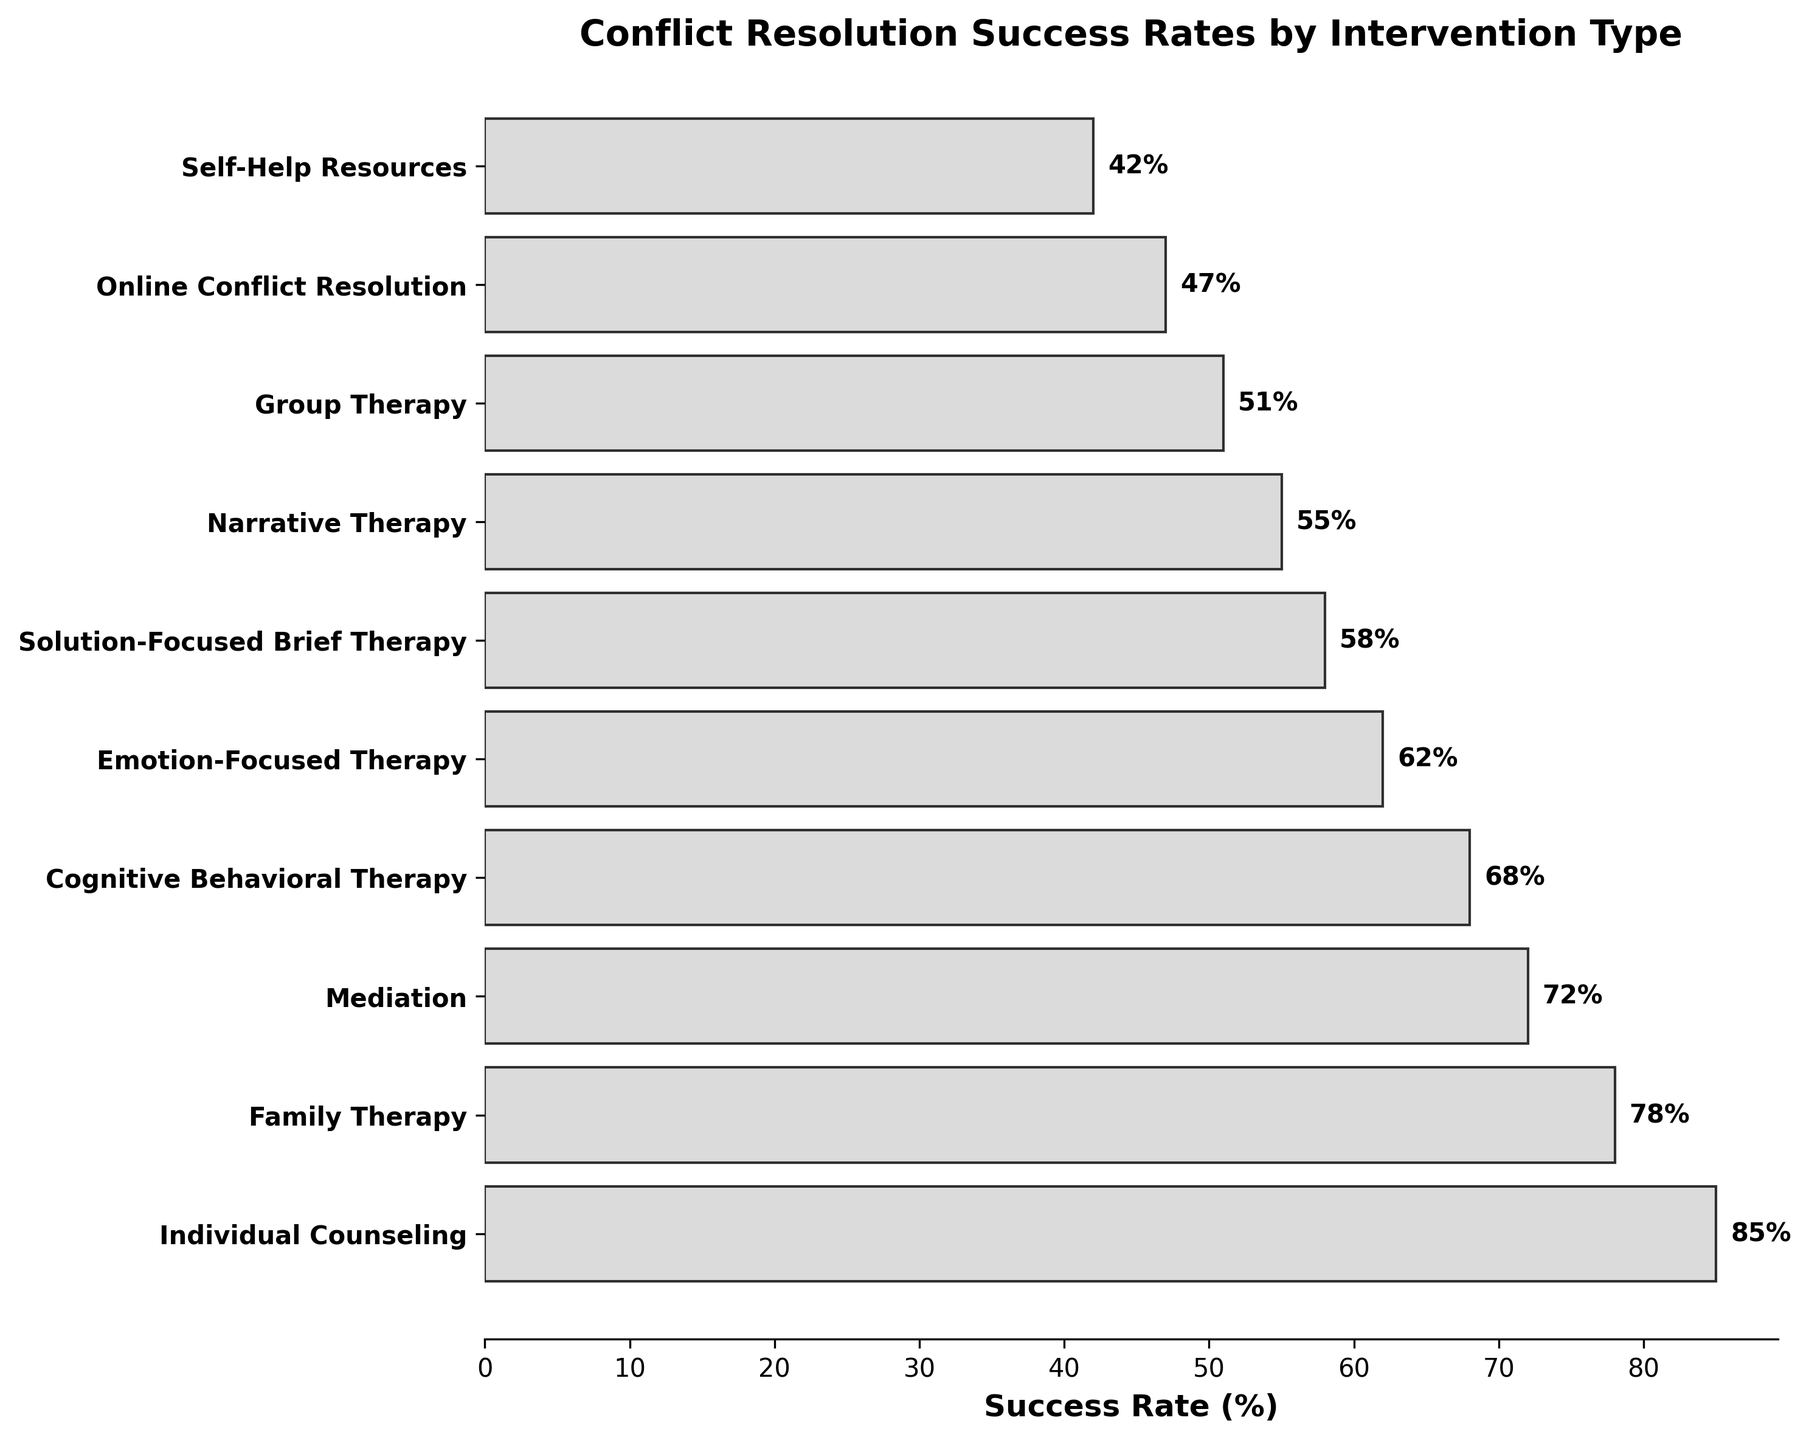What is the title of the figure? The title of the figure is displayed at the top and summarizes the main topic of the plot.
Answer: Conflict Resolution Success Rates by Intervention Type Which intervention type has the highest success rate? The highest bar on the chart represents the intervention type with the highest success rate.
Answer: Individual Counseling What is the success rate of Family Therapy? The success rate of Family Therapy can be found next to the bar labeled "Family Therapy".
Answer: 78% How many intervention types are displayed in the figure? Count the total number of bars in the funnel chart to determine the number of intervention types.
Answer: 10 Which intervention type has the lowest success rate? The shortest bar on the chart represents the intervention type with the lowest success rate.
Answer: Self-Help Resources What is the success rate difference between Individual Counseling and Mediation? Subtract the success rate of Mediation from the success rate of Individual Counseling to find the difference. \[85 (Individual Counseling) - 72 (Mediation) = 13\]
Answer: 13% Arrange the intervention types with success rates above 60% in descending order. Identify the intervention types with success rates over 60% and list them from highest to lowest success rate. \[Individual Counseling (85%), Family Therapy (78%), Mediation (72%), Cognitive Behavioral Therapy (68%), Emotion-Focused Therapy (62%)\]
Answer: Individual Counseling, Family Therapy, Mediation, Cognitive Behavioral Therapy, Emotion-Focused Therapy Which two intervention types have nearly equal success rates? Look for pairs of bars that are of similar lengths and check their labels and values. \[Solution-Focused Brief Therapy (58%) and Narrative Therapy (55%) are close to each other in success rates.\]
Answer: Solution-Focused Brief Therapy and Narrative Therapy What is the combined success rate of Group Therapy and Online Conflict Resolution? Add the success rates of Group Therapy and Online Conflict Resolution together. \[51 (Group Therapy) + 47 (Online Conflict Resolution) = 98\]
Answer: 98% By how much does the success rate of Cognitive Behavioral Therapy exceed that of Self-Help Resources? Subtract the success rate of Self-Help Resources from the success rate of Cognitive Behavioral Therapy. \[68 (Cognitive Behavioral Therapy) - 42 (Self-Help Resources) = 26\]
Answer: 26% 